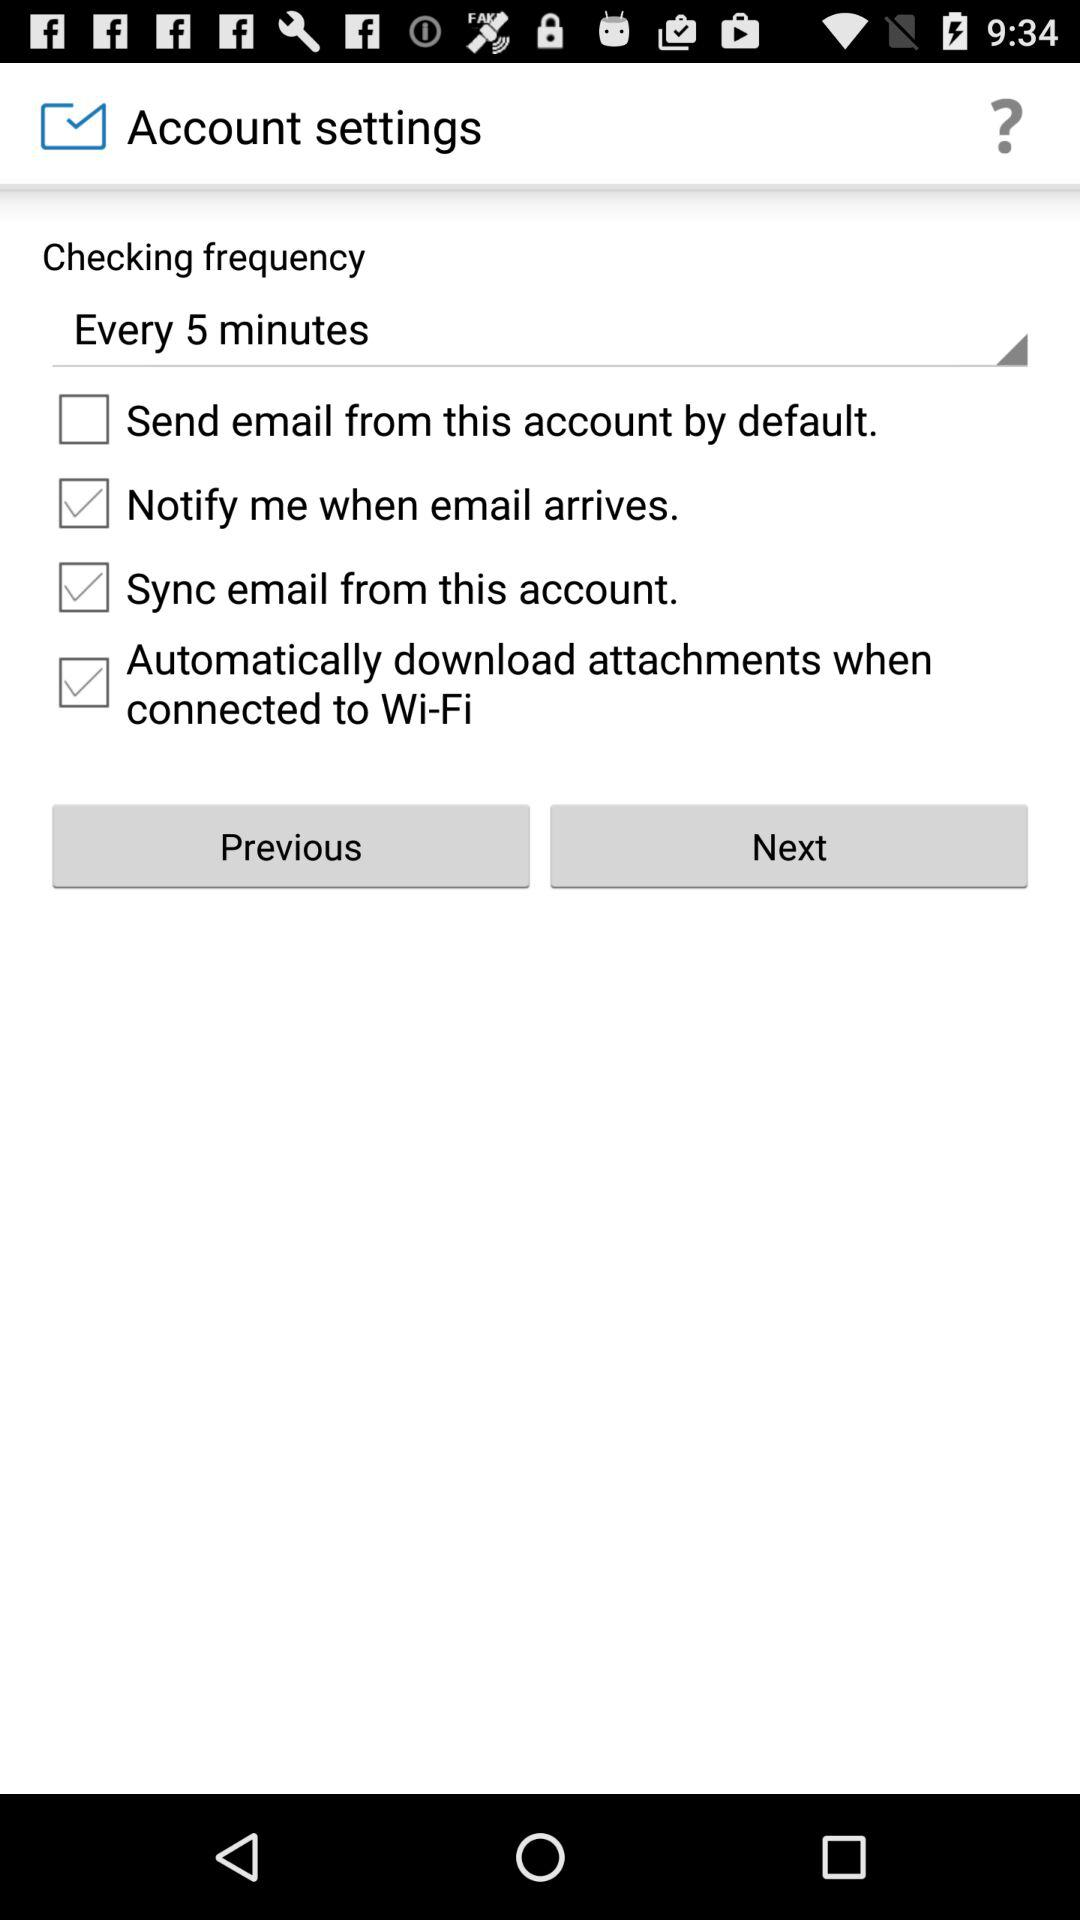What is the status of "Sync email from this account"? The status of "Sync email from this account" is "on". 